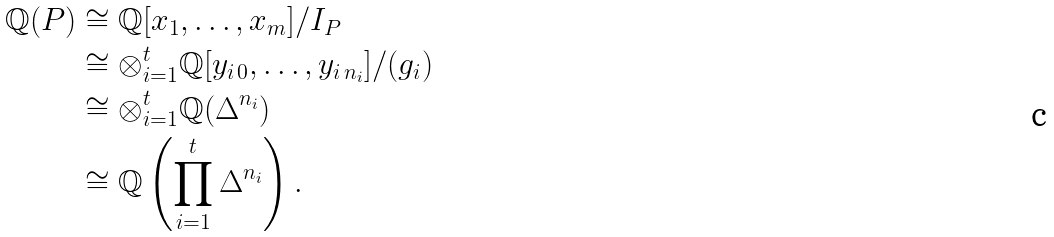Convert formula to latex. <formula><loc_0><loc_0><loc_500><loc_500>\mathbb { Q } ( P ) & \cong \mathbb { Q } [ x _ { 1 } , \dots , x _ { m } ] / I _ { P } \\ & \cong \otimes _ { i = 1 } ^ { t } \mathbb { Q } [ y _ { i \, 0 } , \dots , y _ { i \, { n _ { i } } } ] / ( g _ { i } ) \\ & \cong \otimes _ { i = 1 } ^ { t } \mathbb { Q } ( \Delta ^ { n _ { i } } ) \\ & \cong \mathbb { Q } \left ( \prod _ { i = 1 } ^ { t } \Delta ^ { n _ { i } } \right ) .</formula> 